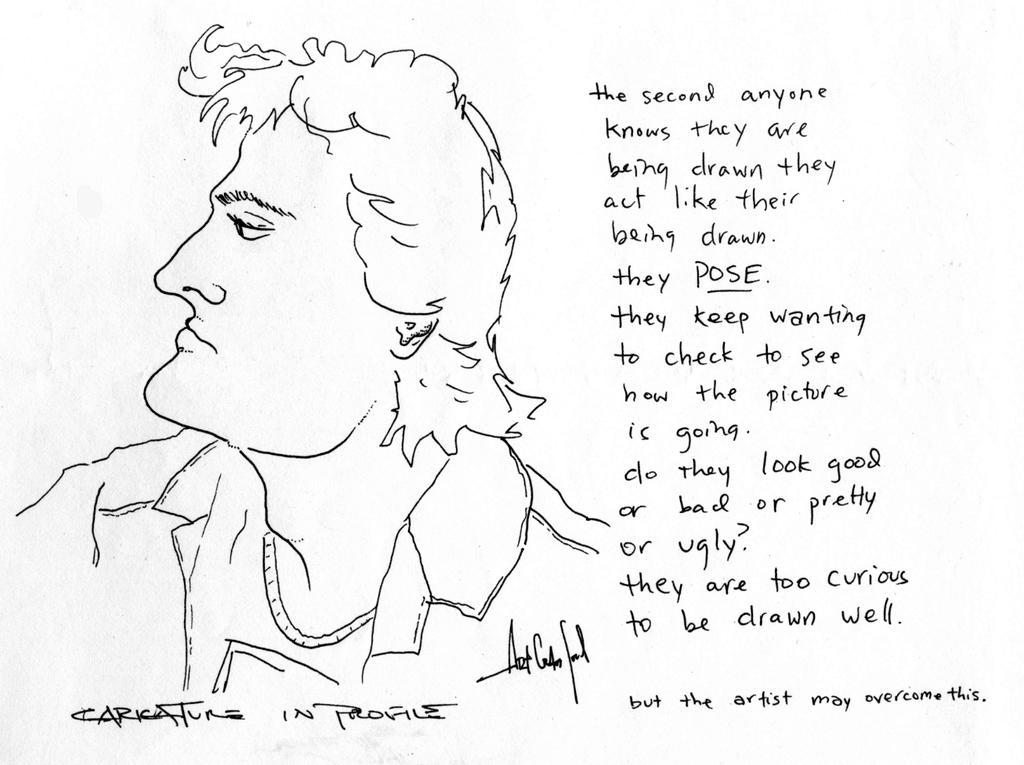In one or two sentences, can you explain what this image depicts? In this image we can see a drawing of a person and some text written on the right side of the image. 